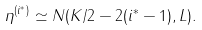<formula> <loc_0><loc_0><loc_500><loc_500>\eta ^ { ( i ^ { \ast } ) } \simeq N ( K / 2 - 2 ( i ^ { \ast } - 1 ) , L ) .</formula> 